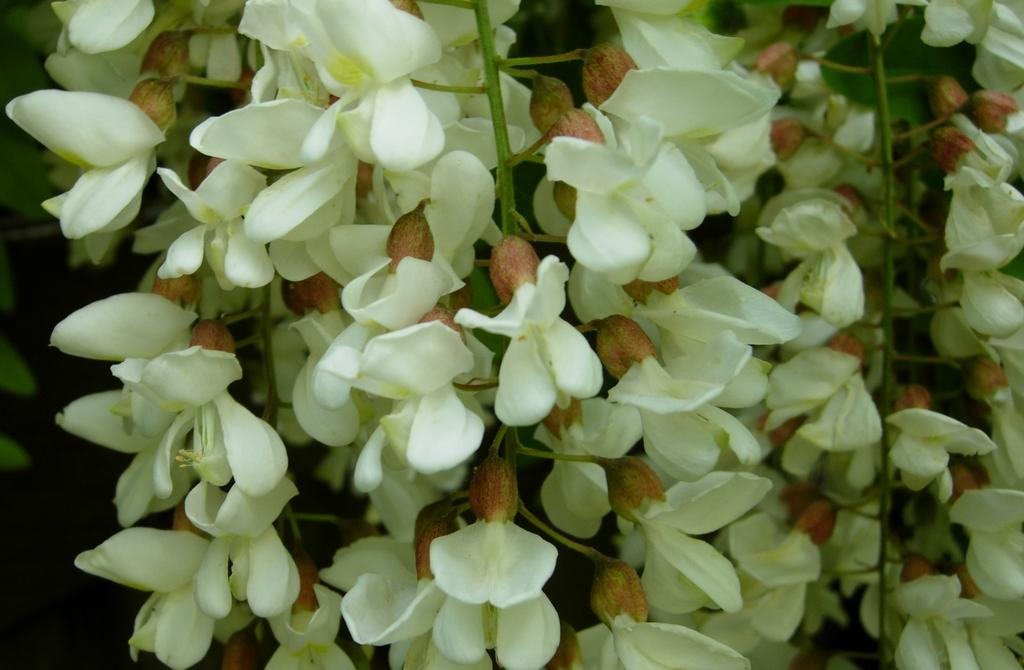What type of flowers can be seen in the image? There are white-colored flowers in the image. How would you describe the overall color scheme of the image? The background of the image appears to be dark. What title is given to the bath in the image? There is no bath present in the image, so there is no title to be given. 